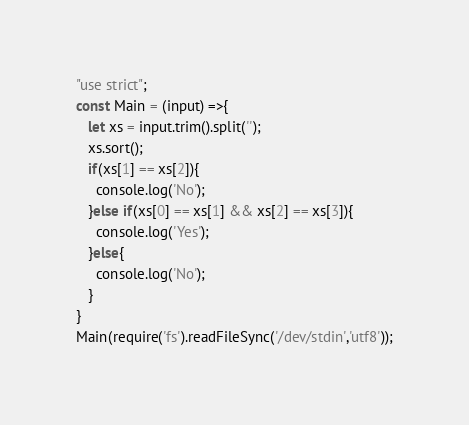Convert code to text. <code><loc_0><loc_0><loc_500><loc_500><_JavaScript_>"use strict";
const Main = (input) =>{
   let xs = input.trim().split('');
   xs.sort(); 
   if(xs[1] == xs[2]){
     console.log('No');
   }else if(xs[0] == xs[1] && xs[2] == xs[3]){
     console.log('Yes');
   }else{
     console.log('No');
   }
}
Main(require('fs').readFileSync('/dev/stdin','utf8'));</code> 